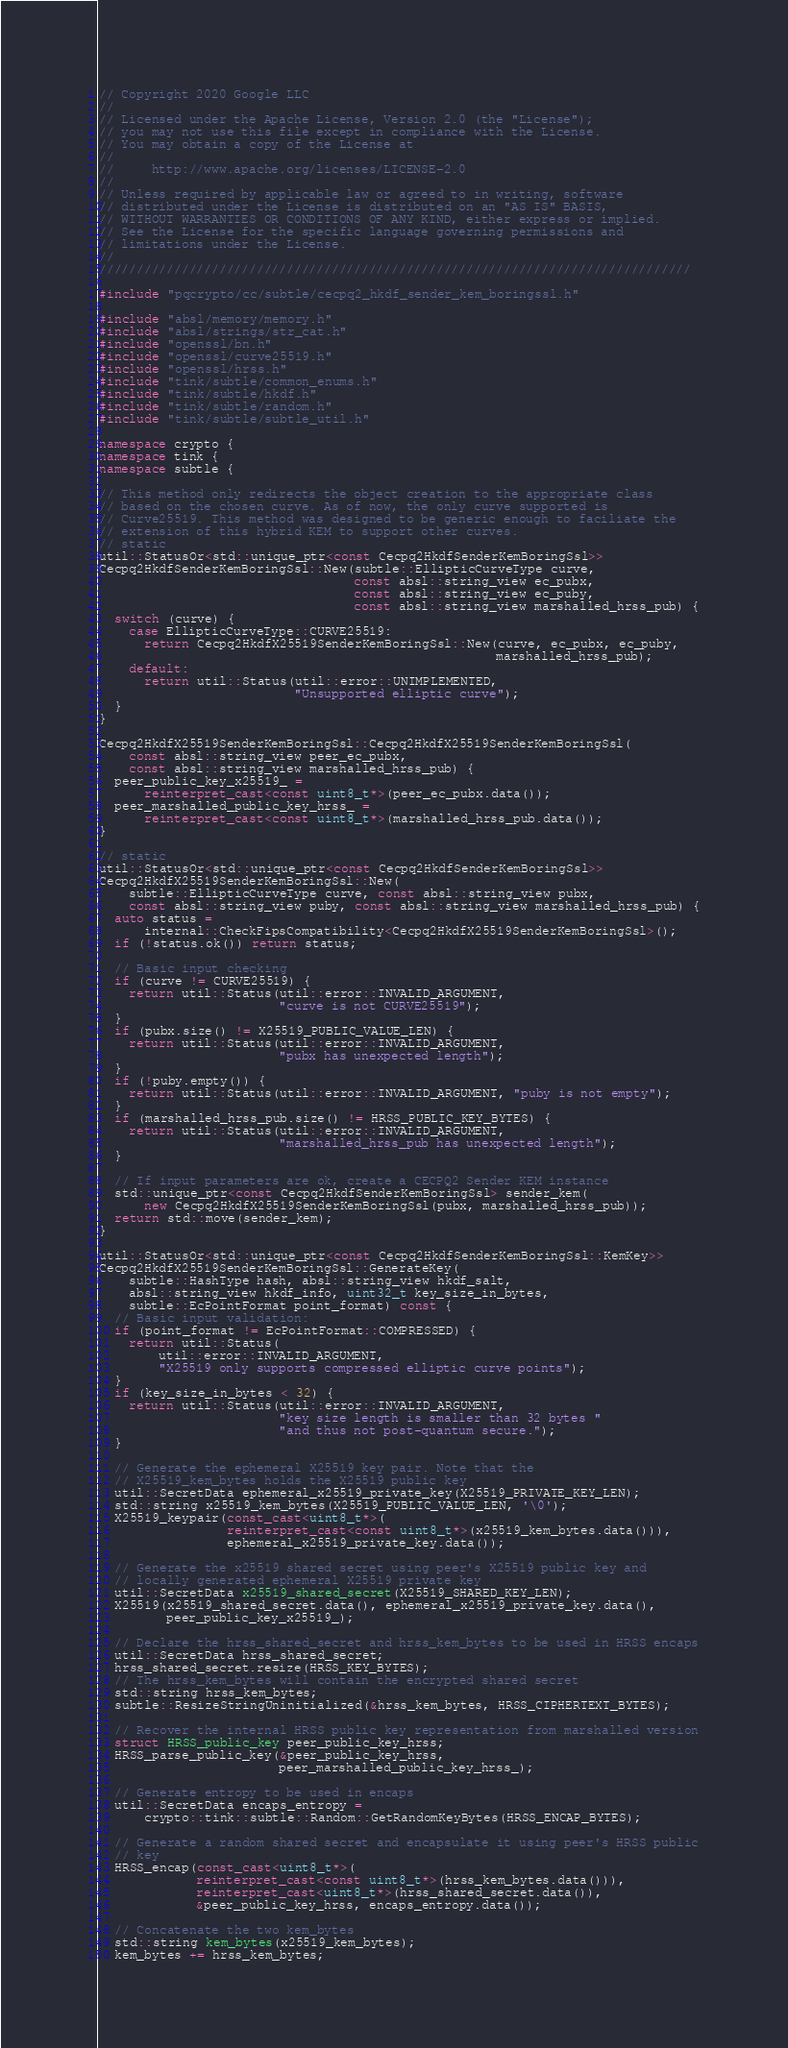Convert code to text. <code><loc_0><loc_0><loc_500><loc_500><_C++_>// Copyright 2020 Google LLC
//
// Licensed under the Apache License, Version 2.0 (the "License");
// you may not use this file except in compliance with the License.
// You may obtain a copy of the License at
//
//     http://www.apache.org/licenses/LICENSE-2.0
//
// Unless required by applicable law or agreed to in writing, software
// distributed under the License is distributed on an "AS IS" BASIS,
// WITHOUT WARRANTIES OR CONDITIONS OF ANY KIND, either express or implied.
// See the License for the specific language governing permissions and
// limitations under the License.
//
///////////////////////////////////////////////////////////////////////////////

#include "pqcrypto/cc/subtle/cecpq2_hkdf_sender_kem_boringssl.h"

#include "absl/memory/memory.h"
#include "absl/strings/str_cat.h"
#include "openssl/bn.h"
#include "openssl/curve25519.h"
#include "openssl/hrss.h"
#include "tink/subtle/common_enums.h"
#include "tink/subtle/hkdf.h"
#include "tink/subtle/random.h"
#include "tink/subtle/subtle_util.h"

namespace crypto {
namespace tink {
namespace subtle {

// This method only redirects the object creation to the appropriate class
// based on the chosen curve. As of now, the only curve supported is
// Curve25519. This method was designed to be generic enough to faciliate the
// extension of this hybrid KEM to support other curves.
// static
util::StatusOr<std::unique_ptr<const Cecpq2HkdfSenderKemBoringSsl>>
Cecpq2HkdfSenderKemBoringSsl::New(subtle::EllipticCurveType curve,
                                  const absl::string_view ec_pubx,
                                  const absl::string_view ec_puby,
                                  const absl::string_view marshalled_hrss_pub) {
  switch (curve) {
    case EllipticCurveType::CURVE25519:
      return Cecpq2HkdfX25519SenderKemBoringSsl::New(curve, ec_pubx, ec_puby,
                                                     marshalled_hrss_pub);
    default:
      return util::Status(util::error::UNIMPLEMENTED,
                          "Unsupported elliptic curve");
  }
}

Cecpq2HkdfX25519SenderKemBoringSsl::Cecpq2HkdfX25519SenderKemBoringSsl(
    const absl::string_view peer_ec_pubx,
    const absl::string_view marshalled_hrss_pub) {
  peer_public_key_x25519_ =
      reinterpret_cast<const uint8_t*>(peer_ec_pubx.data());
  peer_marshalled_public_key_hrss_ =
      reinterpret_cast<const uint8_t*>(marshalled_hrss_pub.data());
}

// static
util::StatusOr<std::unique_ptr<const Cecpq2HkdfSenderKemBoringSsl>>
Cecpq2HkdfX25519SenderKemBoringSsl::New(
    subtle::EllipticCurveType curve, const absl::string_view pubx,
    const absl::string_view puby, const absl::string_view marshalled_hrss_pub) {
  auto status =
      internal::CheckFipsCompatibility<Cecpq2HkdfX25519SenderKemBoringSsl>();
  if (!status.ok()) return status;

  // Basic input checking
  if (curve != CURVE25519) {
    return util::Status(util::error::INVALID_ARGUMENT,
                        "curve is not CURVE25519");
  }
  if (pubx.size() != X25519_PUBLIC_VALUE_LEN) {
    return util::Status(util::error::INVALID_ARGUMENT,
                        "pubx has unexpected length");
  }
  if (!puby.empty()) {
    return util::Status(util::error::INVALID_ARGUMENT, "puby is not empty");
  }
  if (marshalled_hrss_pub.size() != HRSS_PUBLIC_KEY_BYTES) {
    return util::Status(util::error::INVALID_ARGUMENT,
                        "marshalled_hrss_pub has unexpected length");
  }

  // If input parameters are ok, create a CECPQ2 Sender KEM instance
  std::unique_ptr<const Cecpq2HkdfSenderKemBoringSsl> sender_kem(
      new Cecpq2HkdfX25519SenderKemBoringSsl(pubx, marshalled_hrss_pub));
  return std::move(sender_kem);
}

util::StatusOr<std::unique_ptr<const Cecpq2HkdfSenderKemBoringSsl::KemKey>>
Cecpq2HkdfX25519SenderKemBoringSsl::GenerateKey(
    subtle::HashType hash, absl::string_view hkdf_salt,
    absl::string_view hkdf_info, uint32_t key_size_in_bytes,
    subtle::EcPointFormat point_format) const {
  // Basic input validation:
  if (point_format != EcPointFormat::COMPRESSED) {
    return util::Status(
        util::error::INVALID_ARGUMENT,
        "X25519 only supports compressed elliptic curve points");
  }
  if (key_size_in_bytes < 32) {
    return util::Status(util::error::INVALID_ARGUMENT,
                        "key size length is smaller than 32 bytes "
                        "and thus not post-quantum secure.");
  }

  // Generate the ephemeral X25519 key pair. Note that the
  // X25519_kem_bytes holds the X25519 public key
  util::SecretData ephemeral_x25519_private_key(X25519_PRIVATE_KEY_LEN);
  std::string x25519_kem_bytes(X25519_PUBLIC_VALUE_LEN, '\0');
  X25519_keypair(const_cast<uint8_t*>(
                 reinterpret_cast<const uint8_t*>(x25519_kem_bytes.data())),
                 ephemeral_x25519_private_key.data());

  // Generate the x25519 shared secret using peer's X25519 public key and
  // locally generated ephemeral X25519 private key
  util::SecretData x25519_shared_secret(X25519_SHARED_KEY_LEN);
  X25519(x25519_shared_secret.data(), ephemeral_x25519_private_key.data(),
         peer_public_key_x25519_);

  // Declare the hrss_shared_secret and hrss_kem_bytes to be used in HRSS encaps
  util::SecretData hrss_shared_secret;
  hrss_shared_secret.resize(HRSS_KEY_BYTES);
  // The hrss_kem_bytes will contain the encrypted shared secret
  std::string hrss_kem_bytes;
  subtle::ResizeStringUninitialized(&hrss_kem_bytes, HRSS_CIPHERTEXT_BYTES);

  // Recover the internal HRSS public key representation from marshalled version
  struct HRSS_public_key peer_public_key_hrss;
  HRSS_parse_public_key(&peer_public_key_hrss,
                        peer_marshalled_public_key_hrss_);

  // Generate entropy to be used in encaps
  util::SecretData encaps_entropy =
      crypto::tink::subtle::Random::GetRandomKeyBytes(HRSS_ENCAP_BYTES);

  // Generate a random shared secret and encapsulate it using peer's HRSS public
  // key
  HRSS_encap(const_cast<uint8_t*>(
             reinterpret_cast<const uint8_t*>(hrss_kem_bytes.data())),
             reinterpret_cast<uint8_t*>(hrss_shared_secret.data()),
             &peer_public_key_hrss, encaps_entropy.data());

  // Concatenate the two kem_bytes
  std::string kem_bytes(x25519_kem_bytes);
  kem_bytes += hrss_kem_bytes;
</code> 